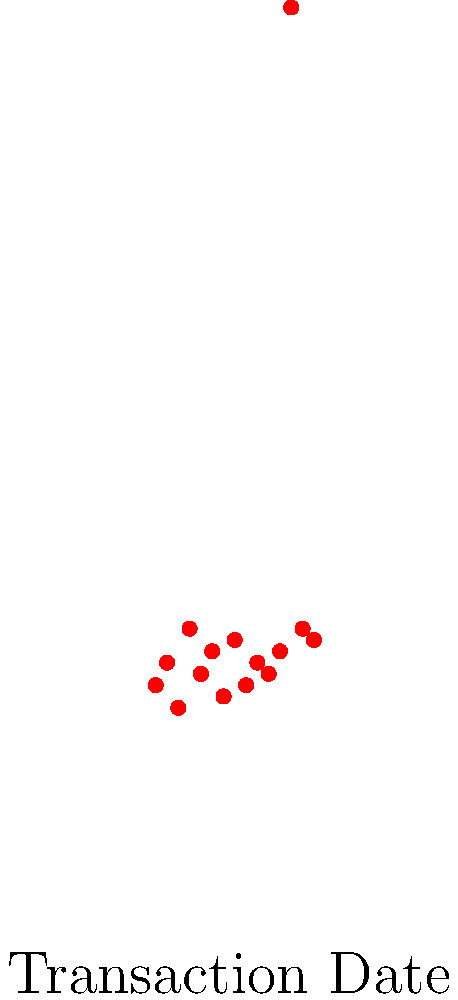As a young orphan learning about financial responsibility, you're analyzing your spending habits using a scatter plot. The plot shows transaction amounts over time. Which point represents an anomaly in your spending pattern, and approximately how much higher is this transaction compared to your average spending? To identify the anomaly and calculate its difference from the average spending:

1. Observe the scatter plot: Most points cluster between $18 and $25.

2. Identify the anomaly: The point at (13, 80) stands out significantly.

3. Calculate the average spending (excluding the anomaly):
   Sum of other transactions: $20 + $22 + $18 + $25 + $21 + $23 + $19 + $24 + $20 + $22 + $21 + $23 + $25 + $24 = $307
   Number of transactions: 14
   Average = $307 / 14 ≈ $21.93

4. Calculate the difference:
   Anomaly amount: $80
   Difference = $80 - $21.93 = $58.07

5. Round to the nearest dollar: $58

The anomaly occurs on day 13 and is approximately $58 higher than the average spending.
Answer: Day 13, $58 higher 